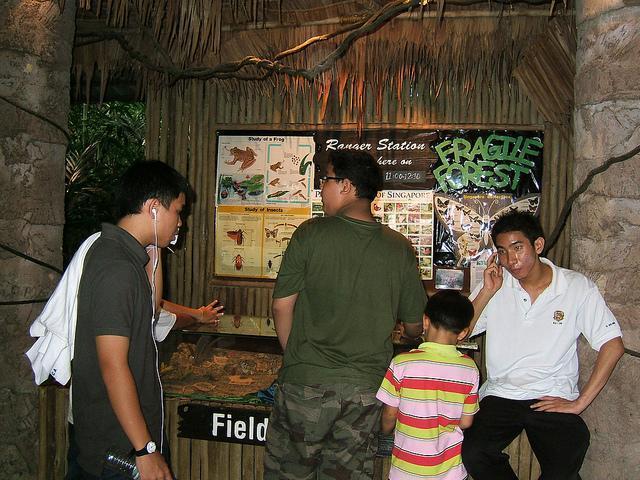How many persons are wearing hats?
Give a very brief answer. 0. How many people are in the picture?
Give a very brief answer. 4. How many trains are on the track?
Give a very brief answer. 0. 